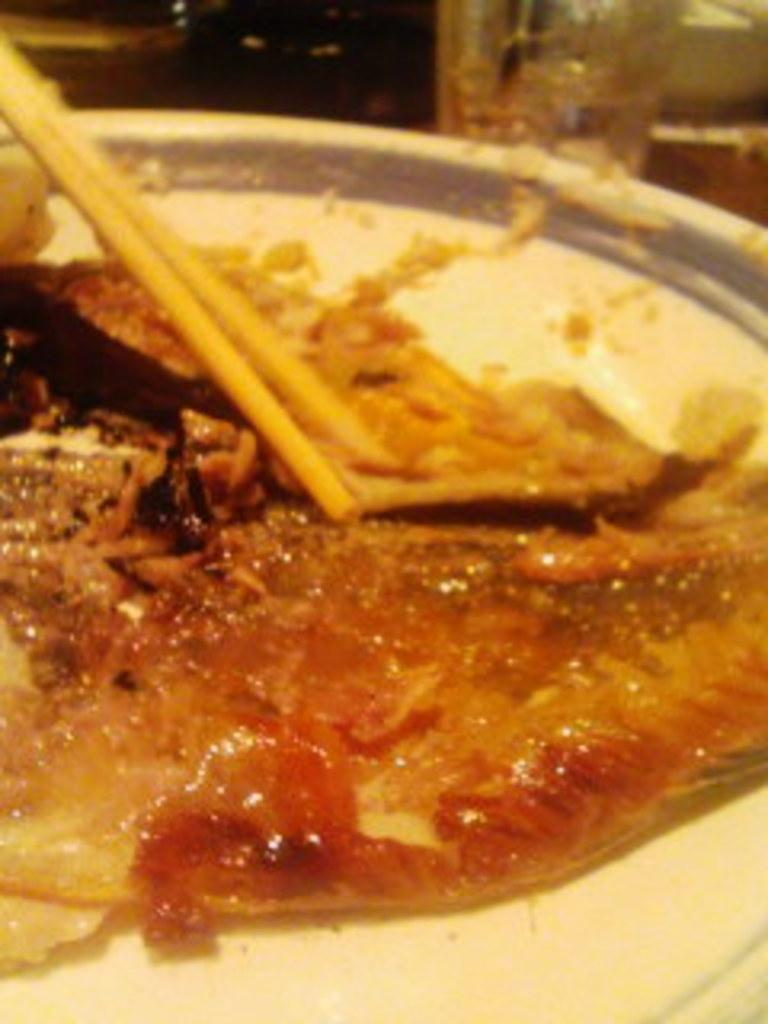What is present on the plate in the image? There are food items on the plate in the image. What utensils are visible in the image? There are two chopsticks in the image. How are the chopsticks being used? The chopsticks are used to hold the food items. What type of wrench is being used to add flavor to the food in the image? There is no wrench present in the image, and no mention of adding flavor to the food. 